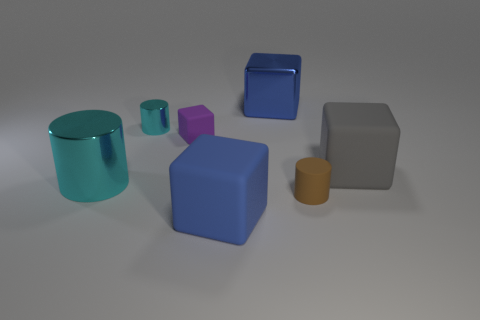Add 2 cyan cylinders. How many objects exist? 9 Subtract all cylinders. How many objects are left? 4 Add 1 big cylinders. How many big cylinders exist? 2 Subtract 0 gray cylinders. How many objects are left? 7 Subtract all small yellow matte objects. Subtract all tiny things. How many objects are left? 4 Add 3 purple rubber cubes. How many purple rubber cubes are left? 4 